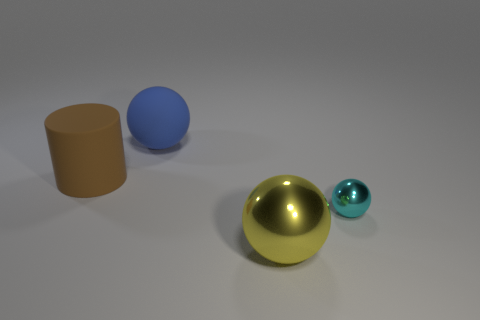There is a sphere right of the big yellow metal sphere; is it the same color as the large cylinder?
Ensure brevity in your answer.  No. How many cylinders are either blue rubber things or small cyan metal things?
Ensure brevity in your answer.  0. There is a big thing to the left of the blue thing; what shape is it?
Offer a terse response. Cylinder. The big rubber thing that is behind the big matte thing that is in front of the large thing behind the big brown thing is what color?
Keep it short and to the point. Blue. Does the blue ball have the same material as the brown cylinder?
Provide a succinct answer. Yes. What number of brown things are large objects or cylinders?
Provide a short and direct response. 1. There is a yellow thing; how many brown rubber objects are on the left side of it?
Provide a short and direct response. 1. Are there more large green rubber balls than large yellow things?
Your answer should be compact. No. The matte object to the left of the large sphere behind the large brown matte thing is what shape?
Give a very brief answer. Cylinder. Is the number of metallic spheres that are in front of the cyan metallic sphere greater than the number of large red matte cubes?
Give a very brief answer. Yes. 